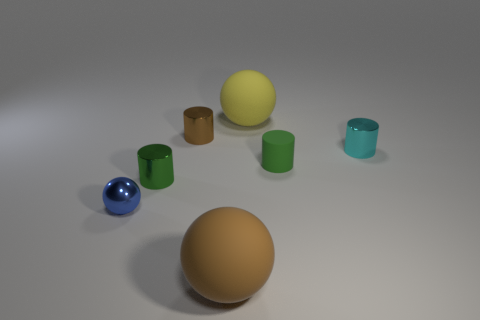Add 1 small yellow matte cylinders. How many objects exist? 8 Subtract all spheres. How many objects are left? 4 Add 4 green cylinders. How many green cylinders are left? 6 Add 6 blue shiny cylinders. How many blue shiny cylinders exist? 6 Subtract 0 green balls. How many objects are left? 7 Subtract all cyan metal cylinders. Subtract all tiny metallic spheres. How many objects are left? 5 